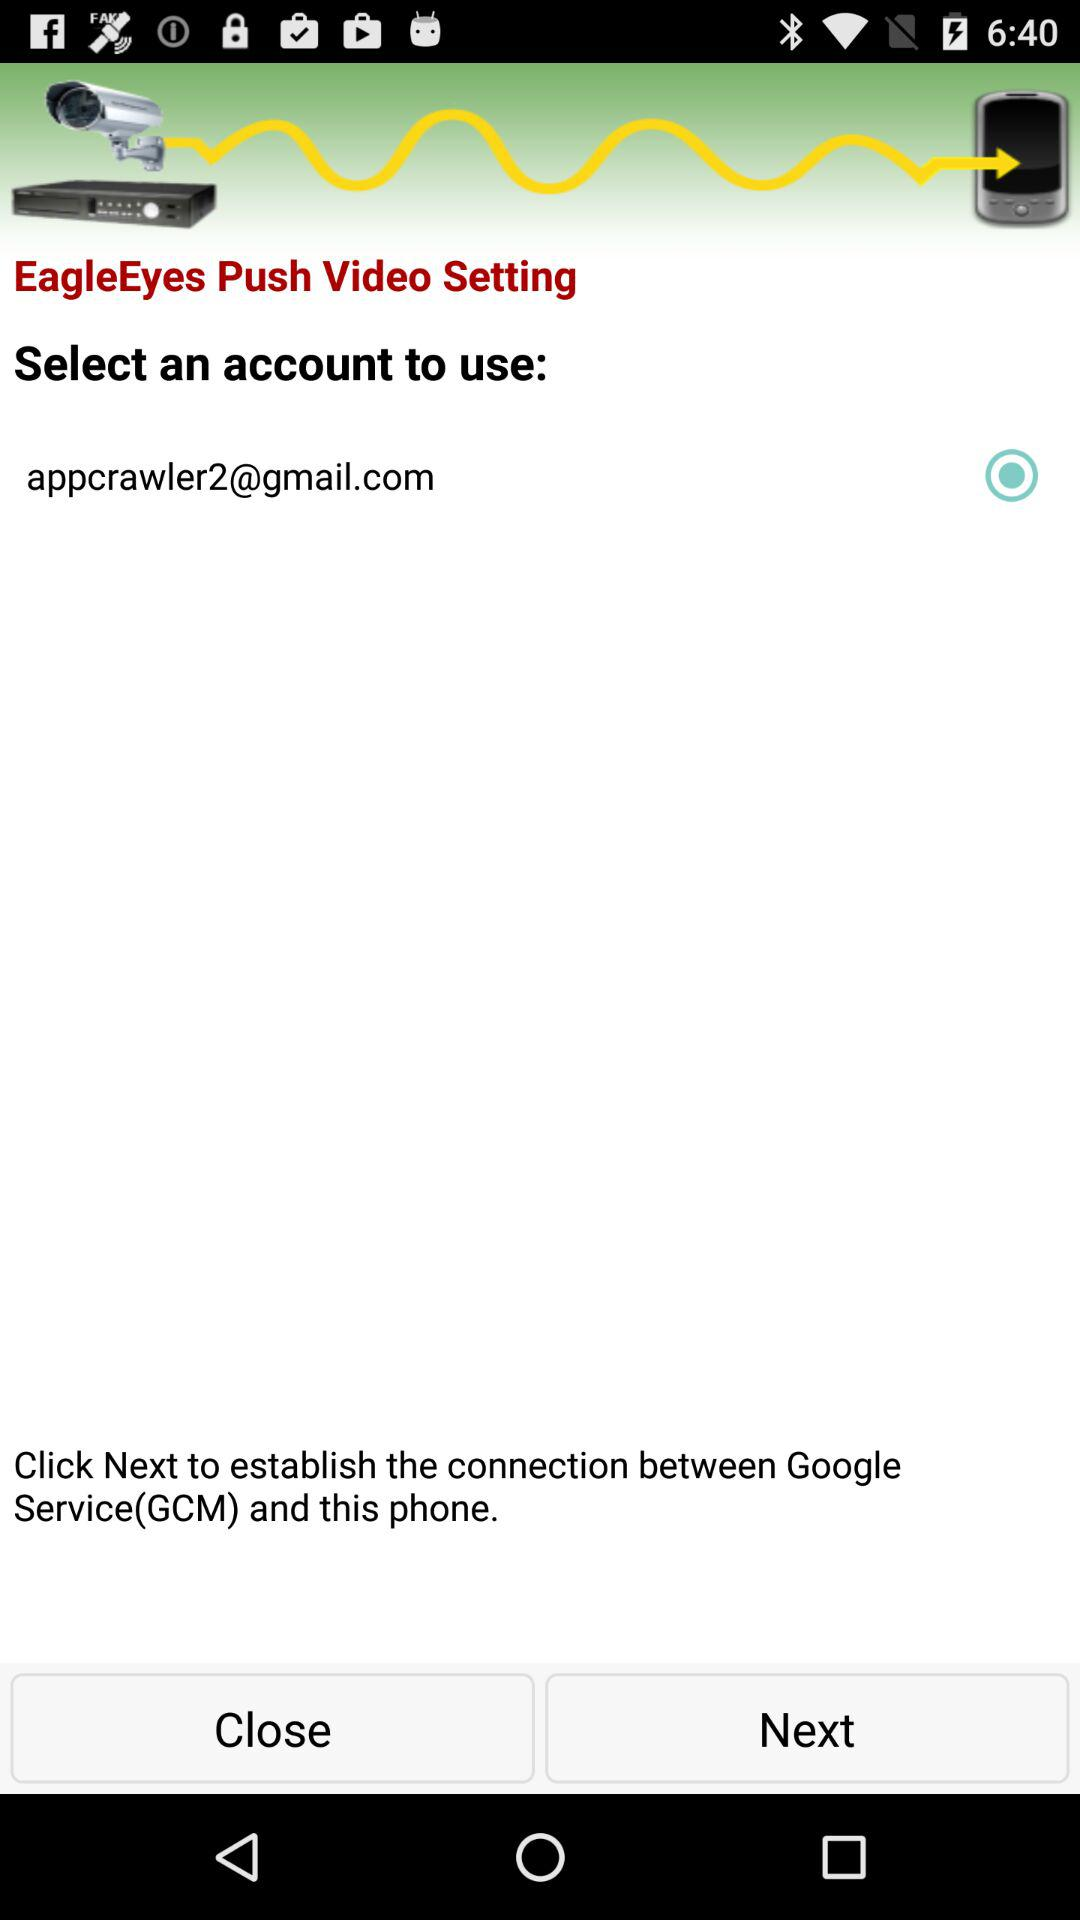What is the name of the application? The name of the application is "EagleEyes". 